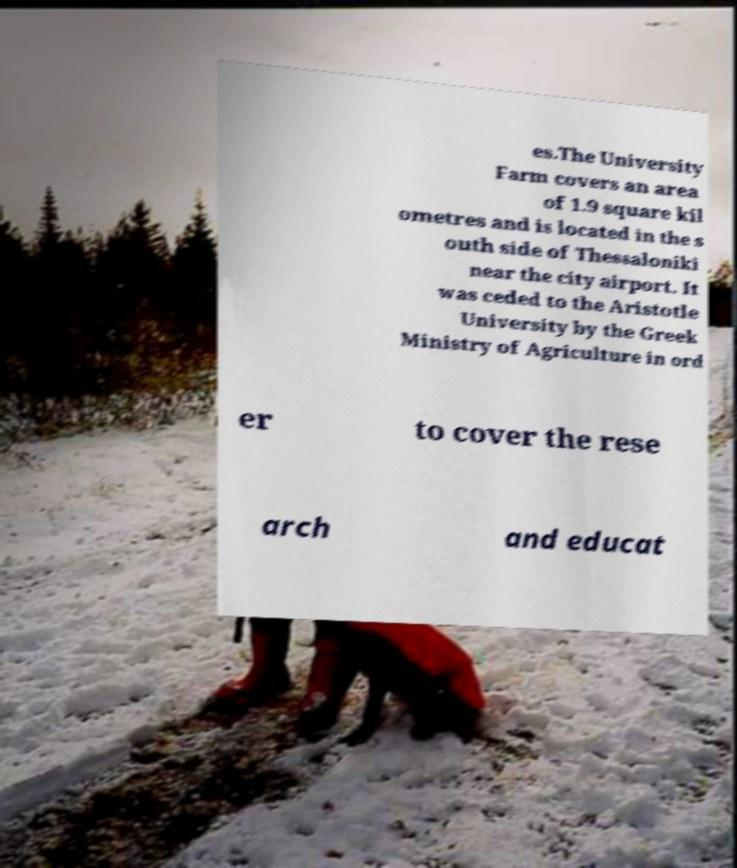I need the written content from this picture converted into text. Can you do that? es.The University Farm covers an area of 1.9 square kil ometres and is located in the s outh side of Thessaloniki near the city airport. It was ceded to the Aristotle University by the Greek Ministry of Agriculture in ord er to cover the rese arch and educat 